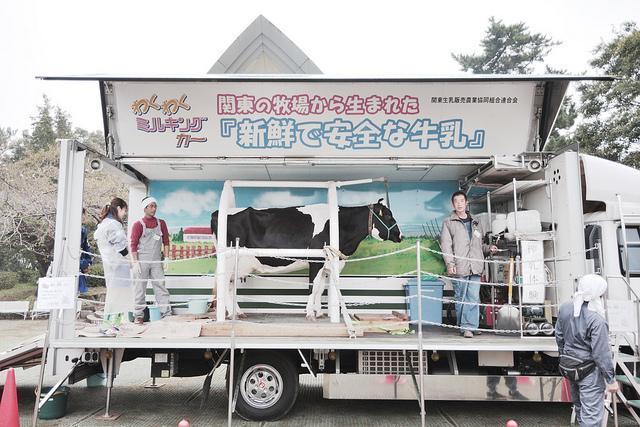Does the caption "The cow is on the truck." correctly depict the image?
Answer yes or no. Yes. Is the given caption "The truck is at the right side of the cow." fitting for the image?
Answer yes or no. No. 